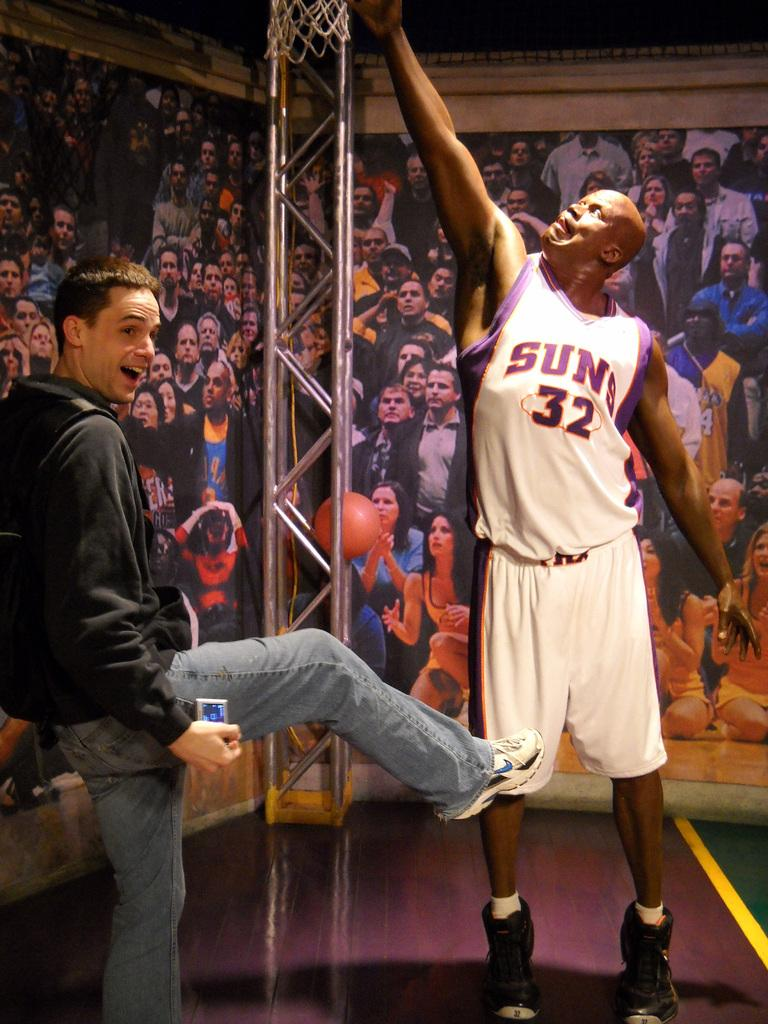<image>
Offer a succinct explanation of the picture presented. A man poses with his leg pointed toward an image of a Suns basketball player. 